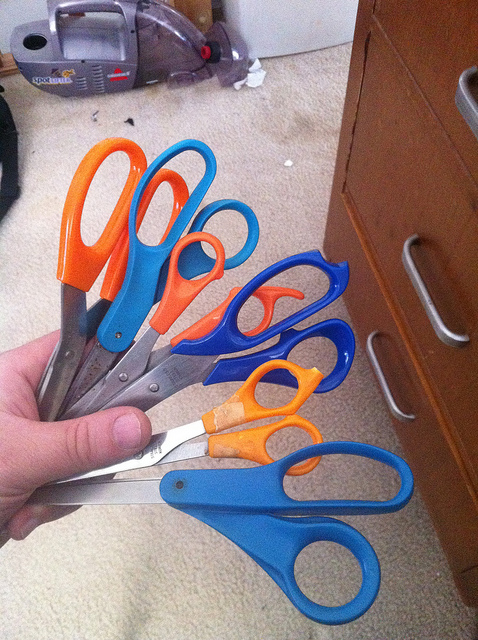What color is the smallest pair of scissors?
A. orange
B. pink
C. black
D. green
Answer with the option's letter from the given choices directly. A 